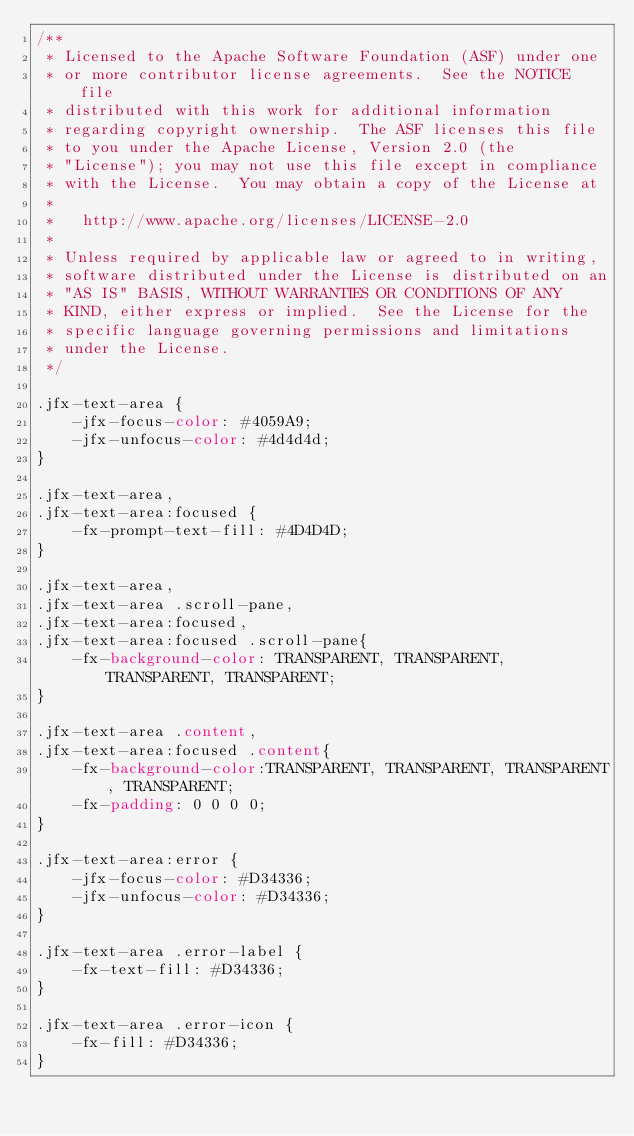Convert code to text. <code><loc_0><loc_0><loc_500><loc_500><_CSS_>/**
 * Licensed to the Apache Software Foundation (ASF) under one
 * or more contributor license agreements.  See the NOTICE file
 * distributed with this work for additional information
 * regarding copyright ownership.  The ASF licenses this file
 * to you under the Apache License, Version 2.0 (the
 * "License"); you may not use this file except in compliance
 * with the License.  You may obtain a copy of the License at
 *
 *   http://www.apache.org/licenses/LICENSE-2.0
 *
 * Unless required by applicable law or agreed to in writing,
 * software distributed under the License is distributed on an
 * "AS IS" BASIS, WITHOUT WARRANTIES OR CONDITIONS OF ANY
 * KIND, either express or implied.  See the License for the
 * specific language governing permissions and limitations
 * under the License.
 */

.jfx-text-area {
    -jfx-focus-color: #4059A9;
    -jfx-unfocus-color: #4d4d4d;
}

.jfx-text-area,
.jfx-text-area:focused {
    -fx-prompt-text-fill: #4D4D4D;
}

.jfx-text-area,
.jfx-text-area .scroll-pane,
.jfx-text-area:focused,
.jfx-text-area:focused .scroll-pane{
    -fx-background-color: TRANSPARENT, TRANSPARENT, TRANSPARENT, TRANSPARENT;
}

.jfx-text-area .content,
.jfx-text-area:focused .content{
    -fx-background-color:TRANSPARENT, TRANSPARENT, TRANSPARENT, TRANSPARENT;
    -fx-padding: 0 0 0 0;
}

.jfx-text-area:error {
    -jfx-focus-color: #D34336;
    -jfx-unfocus-color: #D34336;
}

.jfx-text-area .error-label {
    -fx-text-fill: #D34336;
}

.jfx-text-area .error-icon {
    -fx-fill: #D34336;
}
</code> 